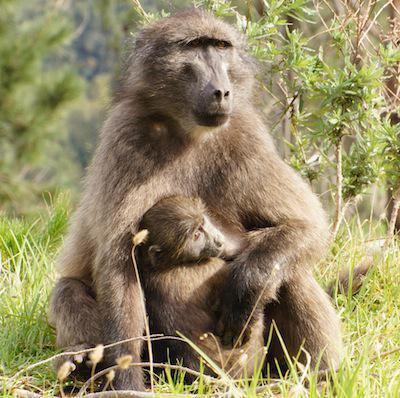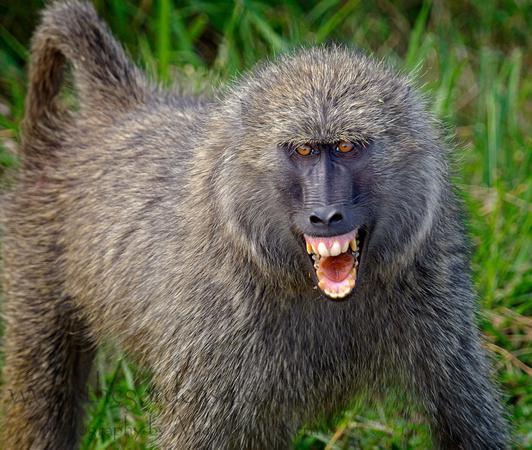The first image is the image on the left, the second image is the image on the right. For the images shown, is this caption "An image shows a juvenile baboon posed with its chest against the chest of an adult baboon." true? Answer yes or no. Yes. The first image is the image on the left, the second image is the image on the right. Considering the images on both sides, is "There is a single monkey looking in the direction of the camera in the image on the right." valid? Answer yes or no. Yes. 